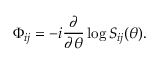Convert formula to latex. <formula><loc_0><loc_0><loc_500><loc_500>\Phi _ { i j } = - i \frac { \partial } { \partial \theta } \log S _ { i j } ( \theta ) .</formula> 